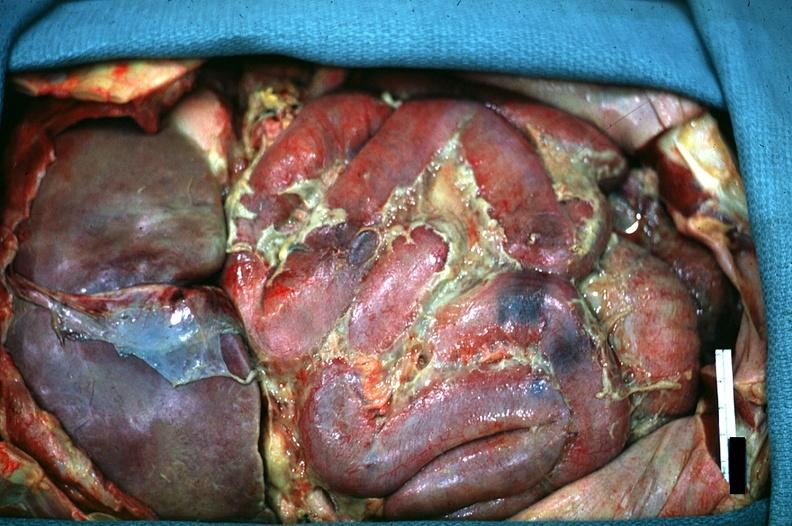s opened abdominal cavity with massive tumor in omentum none apparent in liver nor over peritoneal surfaces gut present?
Answer the question using a single word or phrase. No 